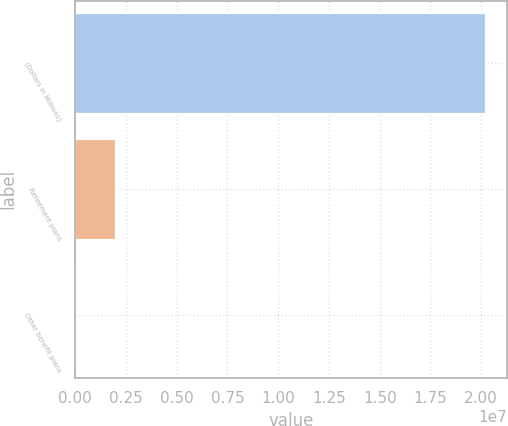Convert chart. <chart><loc_0><loc_0><loc_500><loc_500><bar_chart><fcel>(Dollars in Millions)<fcel>Retirement plans<fcel>Other benefit plans<nl><fcel>2.0242e+07<fcel>2.02625e+06<fcel>2273<nl></chart> 